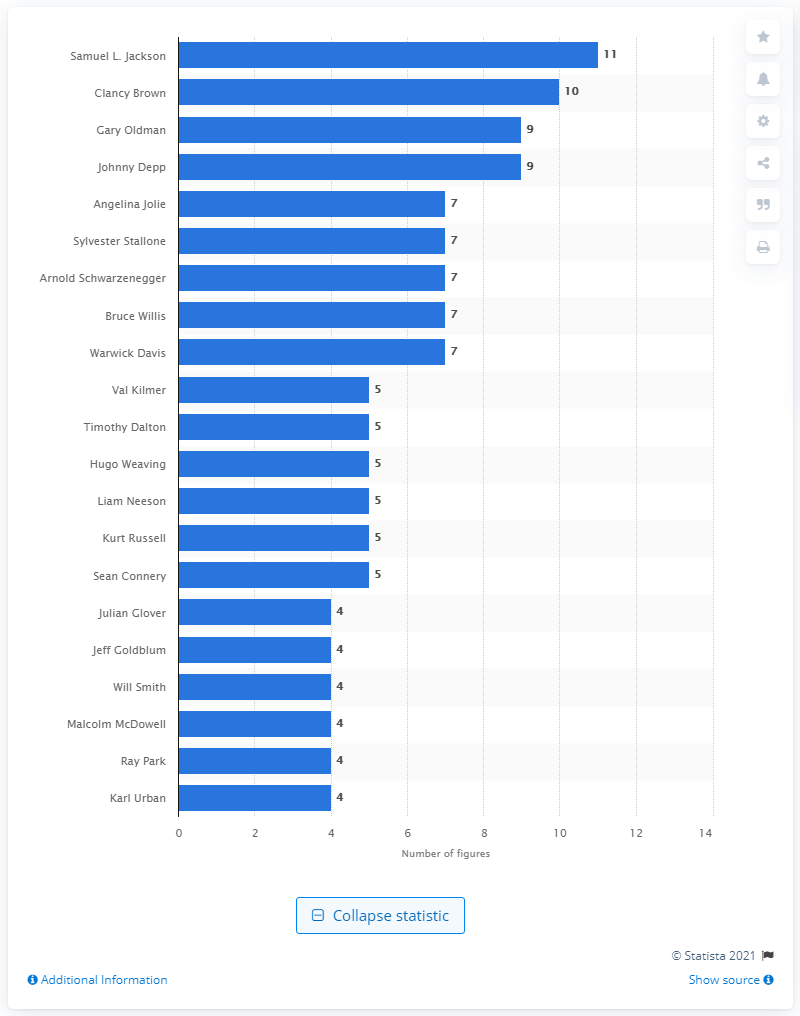Indicate a few pertinent items in this graphic. Samuel L. Jackson had 11 action figures in his collection. 